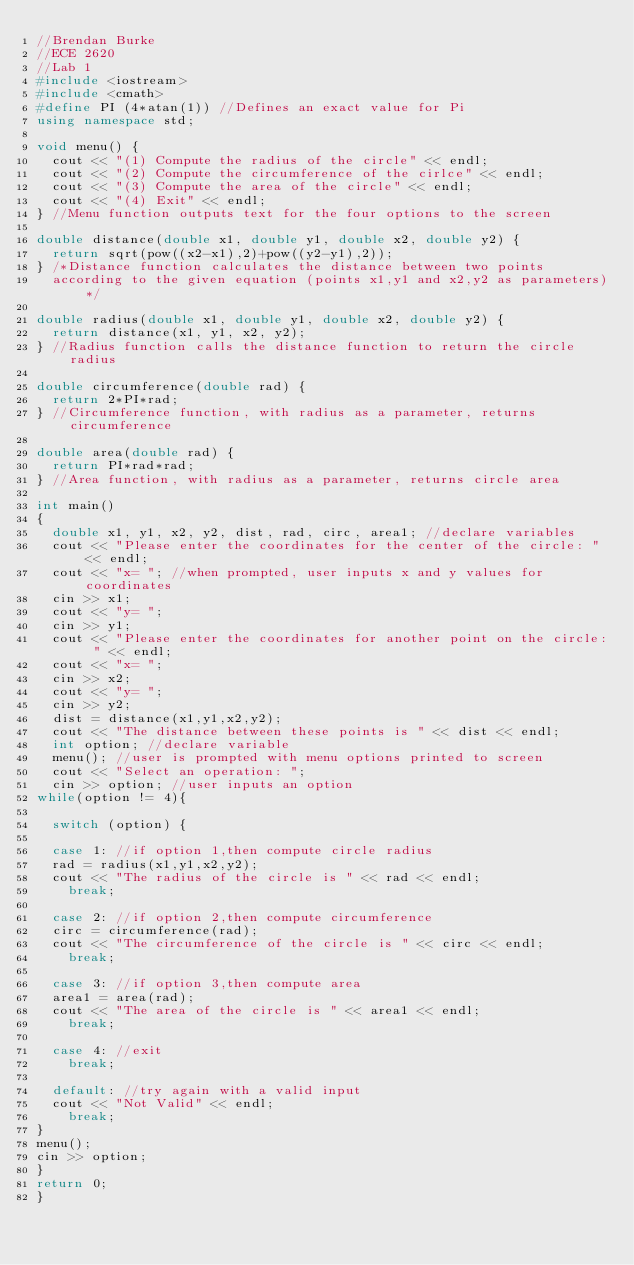<code> <loc_0><loc_0><loc_500><loc_500><_C++_>//Brendan Burke
//ECE 2620
//Lab 1
#include <iostream>
#include <cmath>
#define PI (4*atan(1)) //Defines an exact value for Pi
using namespace std;

void menu() {
	cout << "(1) Compute the radius of the circle" << endl;
	cout << "(2) Compute the circumference of the cirlce" << endl;
	cout << "(3) Compute the area of the circle" << endl;
	cout << "(4) Exit" << endl;
} //Menu function outputs text for the four options to the screen

double distance(double x1, double y1, double x2, double y2) {
	return sqrt(pow((x2-x1),2)+pow((y2-y1),2));
} /*Distance function calculates the distance between two points
	according to the given equation (points x1,y1 and x2,y2 as parameters)*/

double radius(double x1, double y1, double x2, double y2) {
	return distance(x1, y1, x2, y2);
} //Radius function calls the distance function to return the circle radius

double circumference(double rad) {
	return 2*PI*rad;
} //Circumference function, with radius as a parameter, returns circumference

double area(double rad) {
	return PI*rad*rad;
} //Area function, with radius as a parameter, returns circle area

int main()
{
	double x1, y1, x2, y2, dist, rad, circ, area1; //declare variables
	cout << "Please enter the coordinates for the center of the circle: " << endl;
	cout << "x= "; //when prompted, user inputs x and y values for coordinates
	cin >> x1;
	cout << "y= ";
	cin >> y1;
	cout << "Please enter the coordinates for another point on the circle: " << endl;
	cout << "x= ";
	cin >> x2;
	cout << "y= ";
	cin >> y2;
	dist = distance(x1,y1,x2,y2);
	cout << "The distance between these points is " << dist << endl;
	int option; //declare variable
	menu(); //user is prompted with menu options printed to screen
	cout << "Select an operation: ";
	cin >> option; //user inputs an option
while(option != 4){

	switch (option) {

	case 1: //if option 1,then compute circle radius
	rad = radius(x1,y1,x2,y2);
	cout << "The radius of the circle is " << rad << endl;
		break;

	case 2: //if option 2,then compute circumference
	circ = circumference(rad);
	cout << "The circumference of the circle is " << circ << endl;
		break;

	case 3: //if option 3,then compute area
	area1 = area(rad);
	cout << "The area of the circle is " << area1 << endl;
		break;

	case 4: //exit
		break;

	default: //try again with a valid input
	cout << "Not Valid" << endl;
		break;
}
menu();
cin >> option;
}
return 0;
}

</code> 